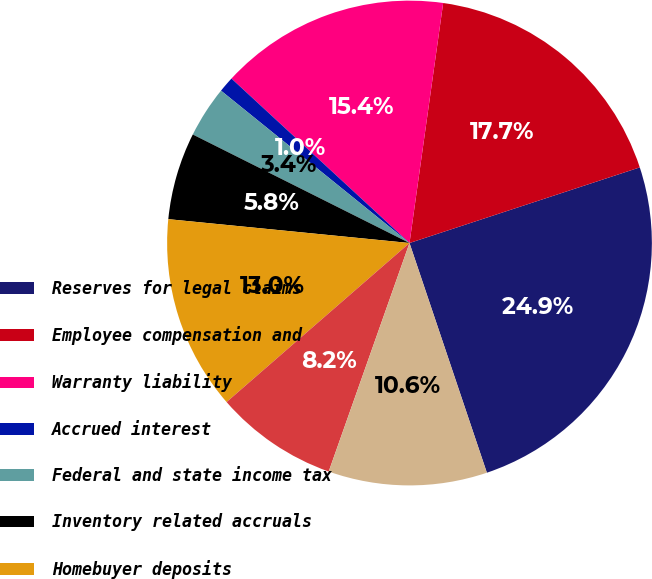Convert chart. <chart><loc_0><loc_0><loc_500><loc_500><pie_chart><fcel>Reserves for legal claims<fcel>Employee compensation and<fcel>Warranty liability<fcel>Accrued interest<fcel>Federal and state income tax<fcel>Inventory related accruals<fcel>Homebuyer deposits<fcel>Accrued property taxes<fcel>Other liabilities<nl><fcel>24.88%<fcel>17.73%<fcel>15.35%<fcel>1.05%<fcel>3.43%<fcel>5.82%<fcel>12.96%<fcel>8.2%<fcel>10.58%<nl></chart> 